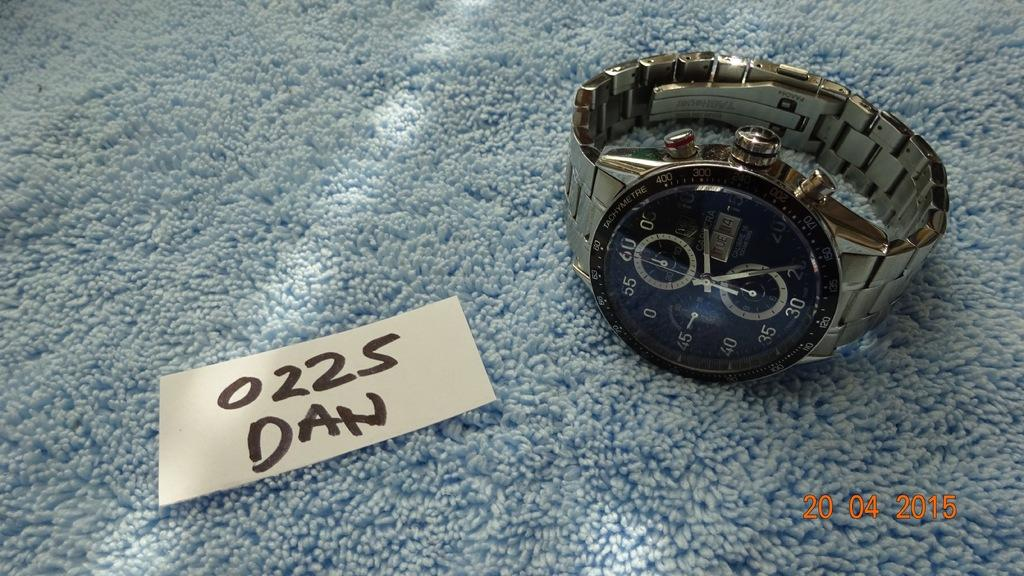Provide a one-sentence caption for the provided image. A watch is on a blue carpet next to a note that says 0225 Dan. 